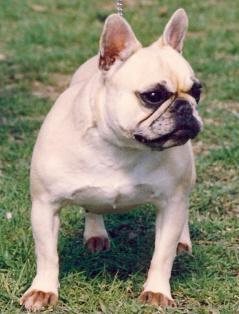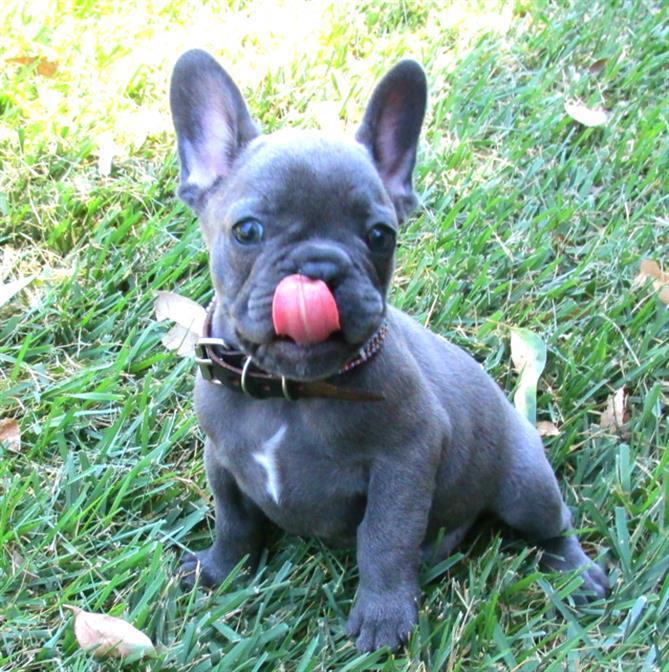The first image is the image on the left, the second image is the image on the right. Examine the images to the left and right. Is the description "One of the dogs has their tongue out at least a little bit." accurate? Answer yes or no. Yes. The first image is the image on the left, the second image is the image on the right. Considering the images on both sides, is "One image shows a charcoal-gray big-eared pup, and one dog in the combined images wears a collar." valid? Answer yes or no. Yes. 